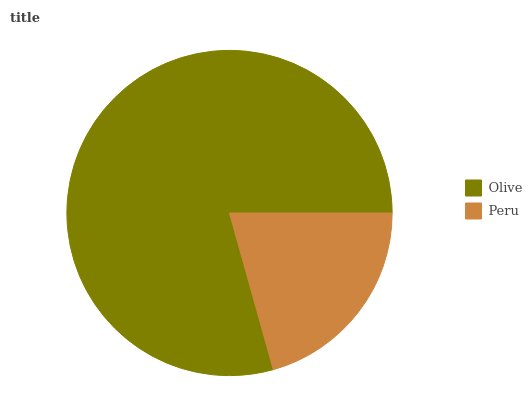Is Peru the minimum?
Answer yes or no. Yes. Is Olive the maximum?
Answer yes or no. Yes. Is Peru the maximum?
Answer yes or no. No. Is Olive greater than Peru?
Answer yes or no. Yes. Is Peru less than Olive?
Answer yes or no. Yes. Is Peru greater than Olive?
Answer yes or no. No. Is Olive less than Peru?
Answer yes or no. No. Is Olive the high median?
Answer yes or no. Yes. Is Peru the low median?
Answer yes or no. Yes. Is Peru the high median?
Answer yes or no. No. Is Olive the low median?
Answer yes or no. No. 